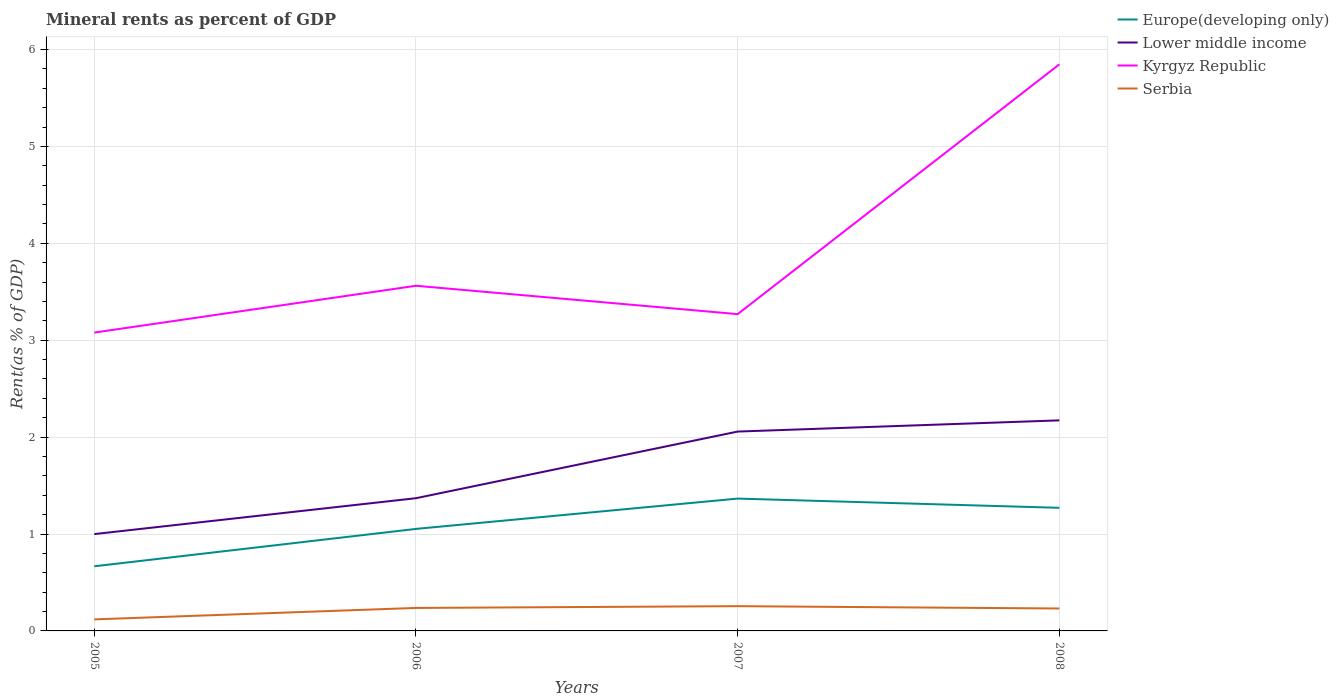Does the line corresponding to Serbia intersect with the line corresponding to Kyrgyz Republic?
Your answer should be very brief. No. Across all years, what is the maximum mineral rent in Kyrgyz Republic?
Provide a succinct answer. 3.08. What is the total mineral rent in Serbia in the graph?
Offer a terse response. -0.14. What is the difference between the highest and the second highest mineral rent in Serbia?
Your answer should be compact. 0.14. How many lines are there?
Your answer should be very brief. 4. Are the values on the major ticks of Y-axis written in scientific E-notation?
Offer a very short reply. No. Does the graph contain any zero values?
Offer a very short reply. No. Does the graph contain grids?
Keep it short and to the point. Yes. How many legend labels are there?
Make the answer very short. 4. What is the title of the graph?
Give a very brief answer. Mineral rents as percent of GDP. What is the label or title of the X-axis?
Give a very brief answer. Years. What is the label or title of the Y-axis?
Your answer should be very brief. Rent(as % of GDP). What is the Rent(as % of GDP) of Europe(developing only) in 2005?
Provide a succinct answer. 0.67. What is the Rent(as % of GDP) in Lower middle income in 2005?
Keep it short and to the point. 1. What is the Rent(as % of GDP) of Kyrgyz Republic in 2005?
Offer a terse response. 3.08. What is the Rent(as % of GDP) of Serbia in 2005?
Make the answer very short. 0.12. What is the Rent(as % of GDP) in Europe(developing only) in 2006?
Keep it short and to the point. 1.05. What is the Rent(as % of GDP) in Lower middle income in 2006?
Your answer should be compact. 1.37. What is the Rent(as % of GDP) in Kyrgyz Republic in 2006?
Provide a short and direct response. 3.56. What is the Rent(as % of GDP) in Serbia in 2006?
Your answer should be very brief. 0.24. What is the Rent(as % of GDP) in Europe(developing only) in 2007?
Your answer should be very brief. 1.37. What is the Rent(as % of GDP) of Lower middle income in 2007?
Your response must be concise. 2.06. What is the Rent(as % of GDP) of Kyrgyz Republic in 2007?
Ensure brevity in your answer.  3.27. What is the Rent(as % of GDP) of Serbia in 2007?
Your answer should be very brief. 0.26. What is the Rent(as % of GDP) of Europe(developing only) in 2008?
Make the answer very short. 1.27. What is the Rent(as % of GDP) of Lower middle income in 2008?
Your response must be concise. 2.17. What is the Rent(as % of GDP) of Kyrgyz Republic in 2008?
Provide a short and direct response. 5.85. What is the Rent(as % of GDP) in Serbia in 2008?
Ensure brevity in your answer.  0.23. Across all years, what is the maximum Rent(as % of GDP) in Europe(developing only)?
Keep it short and to the point. 1.37. Across all years, what is the maximum Rent(as % of GDP) in Lower middle income?
Your answer should be compact. 2.17. Across all years, what is the maximum Rent(as % of GDP) in Kyrgyz Republic?
Your response must be concise. 5.85. Across all years, what is the maximum Rent(as % of GDP) of Serbia?
Your answer should be compact. 0.26. Across all years, what is the minimum Rent(as % of GDP) of Europe(developing only)?
Your answer should be very brief. 0.67. Across all years, what is the minimum Rent(as % of GDP) in Lower middle income?
Offer a terse response. 1. Across all years, what is the minimum Rent(as % of GDP) in Kyrgyz Republic?
Offer a very short reply. 3.08. Across all years, what is the minimum Rent(as % of GDP) of Serbia?
Make the answer very short. 0.12. What is the total Rent(as % of GDP) of Europe(developing only) in the graph?
Your response must be concise. 4.36. What is the total Rent(as % of GDP) in Lower middle income in the graph?
Offer a very short reply. 6.6. What is the total Rent(as % of GDP) in Kyrgyz Republic in the graph?
Offer a very short reply. 15.76. What is the total Rent(as % of GDP) in Serbia in the graph?
Give a very brief answer. 0.84. What is the difference between the Rent(as % of GDP) of Europe(developing only) in 2005 and that in 2006?
Offer a terse response. -0.39. What is the difference between the Rent(as % of GDP) in Lower middle income in 2005 and that in 2006?
Your answer should be very brief. -0.37. What is the difference between the Rent(as % of GDP) of Kyrgyz Republic in 2005 and that in 2006?
Offer a terse response. -0.48. What is the difference between the Rent(as % of GDP) in Serbia in 2005 and that in 2006?
Ensure brevity in your answer.  -0.12. What is the difference between the Rent(as % of GDP) of Europe(developing only) in 2005 and that in 2007?
Offer a very short reply. -0.7. What is the difference between the Rent(as % of GDP) of Lower middle income in 2005 and that in 2007?
Make the answer very short. -1.06. What is the difference between the Rent(as % of GDP) in Kyrgyz Republic in 2005 and that in 2007?
Offer a very short reply. -0.19. What is the difference between the Rent(as % of GDP) in Serbia in 2005 and that in 2007?
Your response must be concise. -0.14. What is the difference between the Rent(as % of GDP) in Europe(developing only) in 2005 and that in 2008?
Give a very brief answer. -0.6. What is the difference between the Rent(as % of GDP) of Lower middle income in 2005 and that in 2008?
Make the answer very short. -1.17. What is the difference between the Rent(as % of GDP) in Kyrgyz Republic in 2005 and that in 2008?
Your answer should be very brief. -2.77. What is the difference between the Rent(as % of GDP) of Serbia in 2005 and that in 2008?
Keep it short and to the point. -0.11. What is the difference between the Rent(as % of GDP) of Europe(developing only) in 2006 and that in 2007?
Your answer should be compact. -0.31. What is the difference between the Rent(as % of GDP) in Lower middle income in 2006 and that in 2007?
Your response must be concise. -0.69. What is the difference between the Rent(as % of GDP) in Kyrgyz Republic in 2006 and that in 2007?
Offer a terse response. 0.29. What is the difference between the Rent(as % of GDP) of Serbia in 2006 and that in 2007?
Offer a very short reply. -0.02. What is the difference between the Rent(as % of GDP) of Europe(developing only) in 2006 and that in 2008?
Offer a very short reply. -0.22. What is the difference between the Rent(as % of GDP) in Lower middle income in 2006 and that in 2008?
Offer a very short reply. -0.8. What is the difference between the Rent(as % of GDP) of Kyrgyz Republic in 2006 and that in 2008?
Make the answer very short. -2.29. What is the difference between the Rent(as % of GDP) in Serbia in 2006 and that in 2008?
Make the answer very short. 0.01. What is the difference between the Rent(as % of GDP) in Europe(developing only) in 2007 and that in 2008?
Keep it short and to the point. 0.1. What is the difference between the Rent(as % of GDP) of Lower middle income in 2007 and that in 2008?
Give a very brief answer. -0.12. What is the difference between the Rent(as % of GDP) of Kyrgyz Republic in 2007 and that in 2008?
Keep it short and to the point. -2.58. What is the difference between the Rent(as % of GDP) in Serbia in 2007 and that in 2008?
Offer a terse response. 0.02. What is the difference between the Rent(as % of GDP) of Europe(developing only) in 2005 and the Rent(as % of GDP) of Lower middle income in 2006?
Provide a succinct answer. -0.7. What is the difference between the Rent(as % of GDP) of Europe(developing only) in 2005 and the Rent(as % of GDP) of Kyrgyz Republic in 2006?
Keep it short and to the point. -2.9. What is the difference between the Rent(as % of GDP) in Europe(developing only) in 2005 and the Rent(as % of GDP) in Serbia in 2006?
Provide a succinct answer. 0.43. What is the difference between the Rent(as % of GDP) in Lower middle income in 2005 and the Rent(as % of GDP) in Kyrgyz Republic in 2006?
Make the answer very short. -2.56. What is the difference between the Rent(as % of GDP) in Lower middle income in 2005 and the Rent(as % of GDP) in Serbia in 2006?
Keep it short and to the point. 0.76. What is the difference between the Rent(as % of GDP) in Kyrgyz Republic in 2005 and the Rent(as % of GDP) in Serbia in 2006?
Your answer should be compact. 2.84. What is the difference between the Rent(as % of GDP) in Europe(developing only) in 2005 and the Rent(as % of GDP) in Lower middle income in 2007?
Offer a very short reply. -1.39. What is the difference between the Rent(as % of GDP) of Europe(developing only) in 2005 and the Rent(as % of GDP) of Kyrgyz Republic in 2007?
Your answer should be compact. -2.6. What is the difference between the Rent(as % of GDP) in Europe(developing only) in 2005 and the Rent(as % of GDP) in Serbia in 2007?
Your response must be concise. 0.41. What is the difference between the Rent(as % of GDP) in Lower middle income in 2005 and the Rent(as % of GDP) in Kyrgyz Republic in 2007?
Your answer should be compact. -2.27. What is the difference between the Rent(as % of GDP) in Lower middle income in 2005 and the Rent(as % of GDP) in Serbia in 2007?
Offer a very short reply. 0.74. What is the difference between the Rent(as % of GDP) of Kyrgyz Republic in 2005 and the Rent(as % of GDP) of Serbia in 2007?
Offer a terse response. 2.82. What is the difference between the Rent(as % of GDP) of Europe(developing only) in 2005 and the Rent(as % of GDP) of Lower middle income in 2008?
Provide a succinct answer. -1.51. What is the difference between the Rent(as % of GDP) in Europe(developing only) in 2005 and the Rent(as % of GDP) in Kyrgyz Republic in 2008?
Give a very brief answer. -5.18. What is the difference between the Rent(as % of GDP) in Europe(developing only) in 2005 and the Rent(as % of GDP) in Serbia in 2008?
Your answer should be compact. 0.44. What is the difference between the Rent(as % of GDP) in Lower middle income in 2005 and the Rent(as % of GDP) in Kyrgyz Republic in 2008?
Make the answer very short. -4.85. What is the difference between the Rent(as % of GDP) of Lower middle income in 2005 and the Rent(as % of GDP) of Serbia in 2008?
Offer a very short reply. 0.77. What is the difference between the Rent(as % of GDP) in Kyrgyz Republic in 2005 and the Rent(as % of GDP) in Serbia in 2008?
Offer a terse response. 2.85. What is the difference between the Rent(as % of GDP) in Europe(developing only) in 2006 and the Rent(as % of GDP) in Lower middle income in 2007?
Ensure brevity in your answer.  -1. What is the difference between the Rent(as % of GDP) in Europe(developing only) in 2006 and the Rent(as % of GDP) in Kyrgyz Republic in 2007?
Provide a succinct answer. -2.22. What is the difference between the Rent(as % of GDP) in Europe(developing only) in 2006 and the Rent(as % of GDP) in Serbia in 2007?
Your answer should be very brief. 0.8. What is the difference between the Rent(as % of GDP) in Lower middle income in 2006 and the Rent(as % of GDP) in Kyrgyz Republic in 2007?
Provide a short and direct response. -1.9. What is the difference between the Rent(as % of GDP) in Lower middle income in 2006 and the Rent(as % of GDP) in Serbia in 2007?
Your answer should be very brief. 1.11. What is the difference between the Rent(as % of GDP) in Kyrgyz Republic in 2006 and the Rent(as % of GDP) in Serbia in 2007?
Make the answer very short. 3.31. What is the difference between the Rent(as % of GDP) of Europe(developing only) in 2006 and the Rent(as % of GDP) of Lower middle income in 2008?
Give a very brief answer. -1.12. What is the difference between the Rent(as % of GDP) in Europe(developing only) in 2006 and the Rent(as % of GDP) in Kyrgyz Republic in 2008?
Offer a terse response. -4.79. What is the difference between the Rent(as % of GDP) in Europe(developing only) in 2006 and the Rent(as % of GDP) in Serbia in 2008?
Your answer should be compact. 0.82. What is the difference between the Rent(as % of GDP) of Lower middle income in 2006 and the Rent(as % of GDP) of Kyrgyz Republic in 2008?
Your response must be concise. -4.48. What is the difference between the Rent(as % of GDP) in Lower middle income in 2006 and the Rent(as % of GDP) in Serbia in 2008?
Provide a short and direct response. 1.14. What is the difference between the Rent(as % of GDP) in Kyrgyz Republic in 2006 and the Rent(as % of GDP) in Serbia in 2008?
Your answer should be very brief. 3.33. What is the difference between the Rent(as % of GDP) in Europe(developing only) in 2007 and the Rent(as % of GDP) in Lower middle income in 2008?
Keep it short and to the point. -0.81. What is the difference between the Rent(as % of GDP) of Europe(developing only) in 2007 and the Rent(as % of GDP) of Kyrgyz Republic in 2008?
Offer a terse response. -4.48. What is the difference between the Rent(as % of GDP) in Europe(developing only) in 2007 and the Rent(as % of GDP) in Serbia in 2008?
Your answer should be compact. 1.13. What is the difference between the Rent(as % of GDP) in Lower middle income in 2007 and the Rent(as % of GDP) in Kyrgyz Republic in 2008?
Give a very brief answer. -3.79. What is the difference between the Rent(as % of GDP) in Lower middle income in 2007 and the Rent(as % of GDP) in Serbia in 2008?
Make the answer very short. 1.83. What is the difference between the Rent(as % of GDP) of Kyrgyz Republic in 2007 and the Rent(as % of GDP) of Serbia in 2008?
Make the answer very short. 3.04. What is the average Rent(as % of GDP) in Europe(developing only) per year?
Your response must be concise. 1.09. What is the average Rent(as % of GDP) in Lower middle income per year?
Your response must be concise. 1.65. What is the average Rent(as % of GDP) in Kyrgyz Republic per year?
Provide a short and direct response. 3.94. What is the average Rent(as % of GDP) in Serbia per year?
Offer a very short reply. 0.21. In the year 2005, what is the difference between the Rent(as % of GDP) of Europe(developing only) and Rent(as % of GDP) of Lower middle income?
Provide a short and direct response. -0.33. In the year 2005, what is the difference between the Rent(as % of GDP) of Europe(developing only) and Rent(as % of GDP) of Kyrgyz Republic?
Offer a terse response. -2.41. In the year 2005, what is the difference between the Rent(as % of GDP) in Europe(developing only) and Rent(as % of GDP) in Serbia?
Offer a terse response. 0.55. In the year 2005, what is the difference between the Rent(as % of GDP) of Lower middle income and Rent(as % of GDP) of Kyrgyz Republic?
Ensure brevity in your answer.  -2.08. In the year 2005, what is the difference between the Rent(as % of GDP) in Lower middle income and Rent(as % of GDP) in Serbia?
Provide a succinct answer. 0.88. In the year 2005, what is the difference between the Rent(as % of GDP) of Kyrgyz Republic and Rent(as % of GDP) of Serbia?
Your answer should be very brief. 2.96. In the year 2006, what is the difference between the Rent(as % of GDP) of Europe(developing only) and Rent(as % of GDP) of Lower middle income?
Your response must be concise. -0.32. In the year 2006, what is the difference between the Rent(as % of GDP) in Europe(developing only) and Rent(as % of GDP) in Kyrgyz Republic?
Offer a terse response. -2.51. In the year 2006, what is the difference between the Rent(as % of GDP) of Europe(developing only) and Rent(as % of GDP) of Serbia?
Keep it short and to the point. 0.82. In the year 2006, what is the difference between the Rent(as % of GDP) in Lower middle income and Rent(as % of GDP) in Kyrgyz Republic?
Your answer should be compact. -2.19. In the year 2006, what is the difference between the Rent(as % of GDP) in Lower middle income and Rent(as % of GDP) in Serbia?
Your answer should be compact. 1.13. In the year 2006, what is the difference between the Rent(as % of GDP) of Kyrgyz Republic and Rent(as % of GDP) of Serbia?
Ensure brevity in your answer.  3.32. In the year 2007, what is the difference between the Rent(as % of GDP) in Europe(developing only) and Rent(as % of GDP) in Lower middle income?
Your answer should be compact. -0.69. In the year 2007, what is the difference between the Rent(as % of GDP) of Europe(developing only) and Rent(as % of GDP) of Kyrgyz Republic?
Make the answer very short. -1.9. In the year 2007, what is the difference between the Rent(as % of GDP) in Europe(developing only) and Rent(as % of GDP) in Serbia?
Make the answer very short. 1.11. In the year 2007, what is the difference between the Rent(as % of GDP) of Lower middle income and Rent(as % of GDP) of Kyrgyz Republic?
Give a very brief answer. -1.21. In the year 2007, what is the difference between the Rent(as % of GDP) of Lower middle income and Rent(as % of GDP) of Serbia?
Make the answer very short. 1.8. In the year 2007, what is the difference between the Rent(as % of GDP) in Kyrgyz Republic and Rent(as % of GDP) in Serbia?
Give a very brief answer. 3.01. In the year 2008, what is the difference between the Rent(as % of GDP) of Europe(developing only) and Rent(as % of GDP) of Lower middle income?
Keep it short and to the point. -0.9. In the year 2008, what is the difference between the Rent(as % of GDP) in Europe(developing only) and Rent(as % of GDP) in Kyrgyz Republic?
Offer a very short reply. -4.58. In the year 2008, what is the difference between the Rent(as % of GDP) in Europe(developing only) and Rent(as % of GDP) in Serbia?
Give a very brief answer. 1.04. In the year 2008, what is the difference between the Rent(as % of GDP) in Lower middle income and Rent(as % of GDP) in Kyrgyz Republic?
Make the answer very short. -3.67. In the year 2008, what is the difference between the Rent(as % of GDP) in Lower middle income and Rent(as % of GDP) in Serbia?
Provide a short and direct response. 1.94. In the year 2008, what is the difference between the Rent(as % of GDP) of Kyrgyz Republic and Rent(as % of GDP) of Serbia?
Keep it short and to the point. 5.62. What is the ratio of the Rent(as % of GDP) of Europe(developing only) in 2005 to that in 2006?
Ensure brevity in your answer.  0.63. What is the ratio of the Rent(as % of GDP) of Lower middle income in 2005 to that in 2006?
Your response must be concise. 0.73. What is the ratio of the Rent(as % of GDP) in Kyrgyz Republic in 2005 to that in 2006?
Give a very brief answer. 0.86. What is the ratio of the Rent(as % of GDP) of Serbia in 2005 to that in 2006?
Keep it short and to the point. 0.5. What is the ratio of the Rent(as % of GDP) of Europe(developing only) in 2005 to that in 2007?
Provide a succinct answer. 0.49. What is the ratio of the Rent(as % of GDP) of Lower middle income in 2005 to that in 2007?
Offer a terse response. 0.49. What is the ratio of the Rent(as % of GDP) of Kyrgyz Republic in 2005 to that in 2007?
Your answer should be compact. 0.94. What is the ratio of the Rent(as % of GDP) in Serbia in 2005 to that in 2007?
Your response must be concise. 0.47. What is the ratio of the Rent(as % of GDP) in Europe(developing only) in 2005 to that in 2008?
Your answer should be compact. 0.53. What is the ratio of the Rent(as % of GDP) of Lower middle income in 2005 to that in 2008?
Your response must be concise. 0.46. What is the ratio of the Rent(as % of GDP) of Kyrgyz Republic in 2005 to that in 2008?
Give a very brief answer. 0.53. What is the ratio of the Rent(as % of GDP) of Serbia in 2005 to that in 2008?
Your answer should be very brief. 0.51. What is the ratio of the Rent(as % of GDP) of Europe(developing only) in 2006 to that in 2007?
Ensure brevity in your answer.  0.77. What is the ratio of the Rent(as % of GDP) in Lower middle income in 2006 to that in 2007?
Ensure brevity in your answer.  0.67. What is the ratio of the Rent(as % of GDP) of Kyrgyz Republic in 2006 to that in 2007?
Make the answer very short. 1.09. What is the ratio of the Rent(as % of GDP) in Europe(developing only) in 2006 to that in 2008?
Offer a terse response. 0.83. What is the ratio of the Rent(as % of GDP) of Lower middle income in 2006 to that in 2008?
Make the answer very short. 0.63. What is the ratio of the Rent(as % of GDP) in Kyrgyz Republic in 2006 to that in 2008?
Your answer should be very brief. 0.61. What is the ratio of the Rent(as % of GDP) in Serbia in 2006 to that in 2008?
Provide a succinct answer. 1.02. What is the ratio of the Rent(as % of GDP) of Europe(developing only) in 2007 to that in 2008?
Your answer should be very brief. 1.07. What is the ratio of the Rent(as % of GDP) of Lower middle income in 2007 to that in 2008?
Ensure brevity in your answer.  0.95. What is the ratio of the Rent(as % of GDP) of Kyrgyz Republic in 2007 to that in 2008?
Provide a succinct answer. 0.56. What is the ratio of the Rent(as % of GDP) in Serbia in 2007 to that in 2008?
Offer a terse response. 1.1. What is the difference between the highest and the second highest Rent(as % of GDP) in Europe(developing only)?
Ensure brevity in your answer.  0.1. What is the difference between the highest and the second highest Rent(as % of GDP) of Lower middle income?
Make the answer very short. 0.12. What is the difference between the highest and the second highest Rent(as % of GDP) in Kyrgyz Republic?
Ensure brevity in your answer.  2.29. What is the difference between the highest and the second highest Rent(as % of GDP) of Serbia?
Your answer should be very brief. 0.02. What is the difference between the highest and the lowest Rent(as % of GDP) in Europe(developing only)?
Your answer should be very brief. 0.7. What is the difference between the highest and the lowest Rent(as % of GDP) in Lower middle income?
Offer a very short reply. 1.17. What is the difference between the highest and the lowest Rent(as % of GDP) in Kyrgyz Republic?
Make the answer very short. 2.77. What is the difference between the highest and the lowest Rent(as % of GDP) of Serbia?
Your response must be concise. 0.14. 